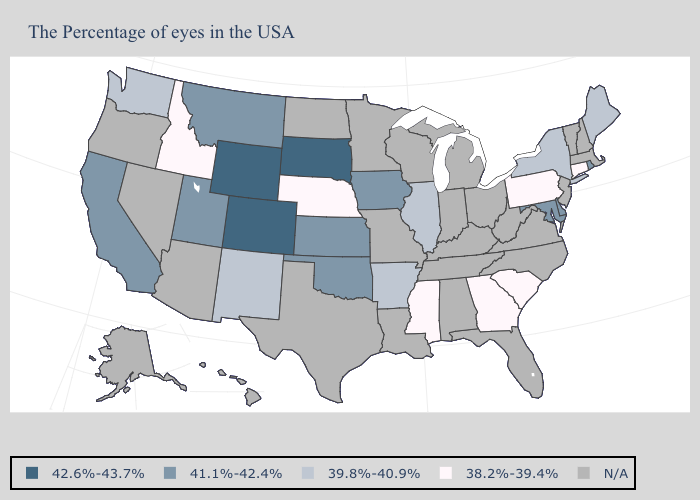Which states have the lowest value in the South?
Be succinct. South Carolina, Georgia, Mississippi. Among the states that border Nevada , which have the highest value?
Be succinct. Utah, California. What is the highest value in the USA?
Write a very short answer. 42.6%-43.7%. Name the states that have a value in the range 38.2%-39.4%?
Write a very short answer. Connecticut, Pennsylvania, South Carolina, Georgia, Mississippi, Nebraska, Idaho. Does Arkansas have the lowest value in the USA?
Write a very short answer. No. What is the highest value in states that border Virginia?
Answer briefly. 41.1%-42.4%. What is the highest value in the USA?
Quick response, please. 42.6%-43.7%. Does Washington have the lowest value in the USA?
Write a very short answer. No. Among the states that border Texas , does New Mexico have the lowest value?
Answer briefly. Yes. What is the highest value in the MidWest ?
Give a very brief answer. 42.6%-43.7%. What is the highest value in the South ?
Be succinct. 41.1%-42.4%. How many symbols are there in the legend?
Answer briefly. 5. 